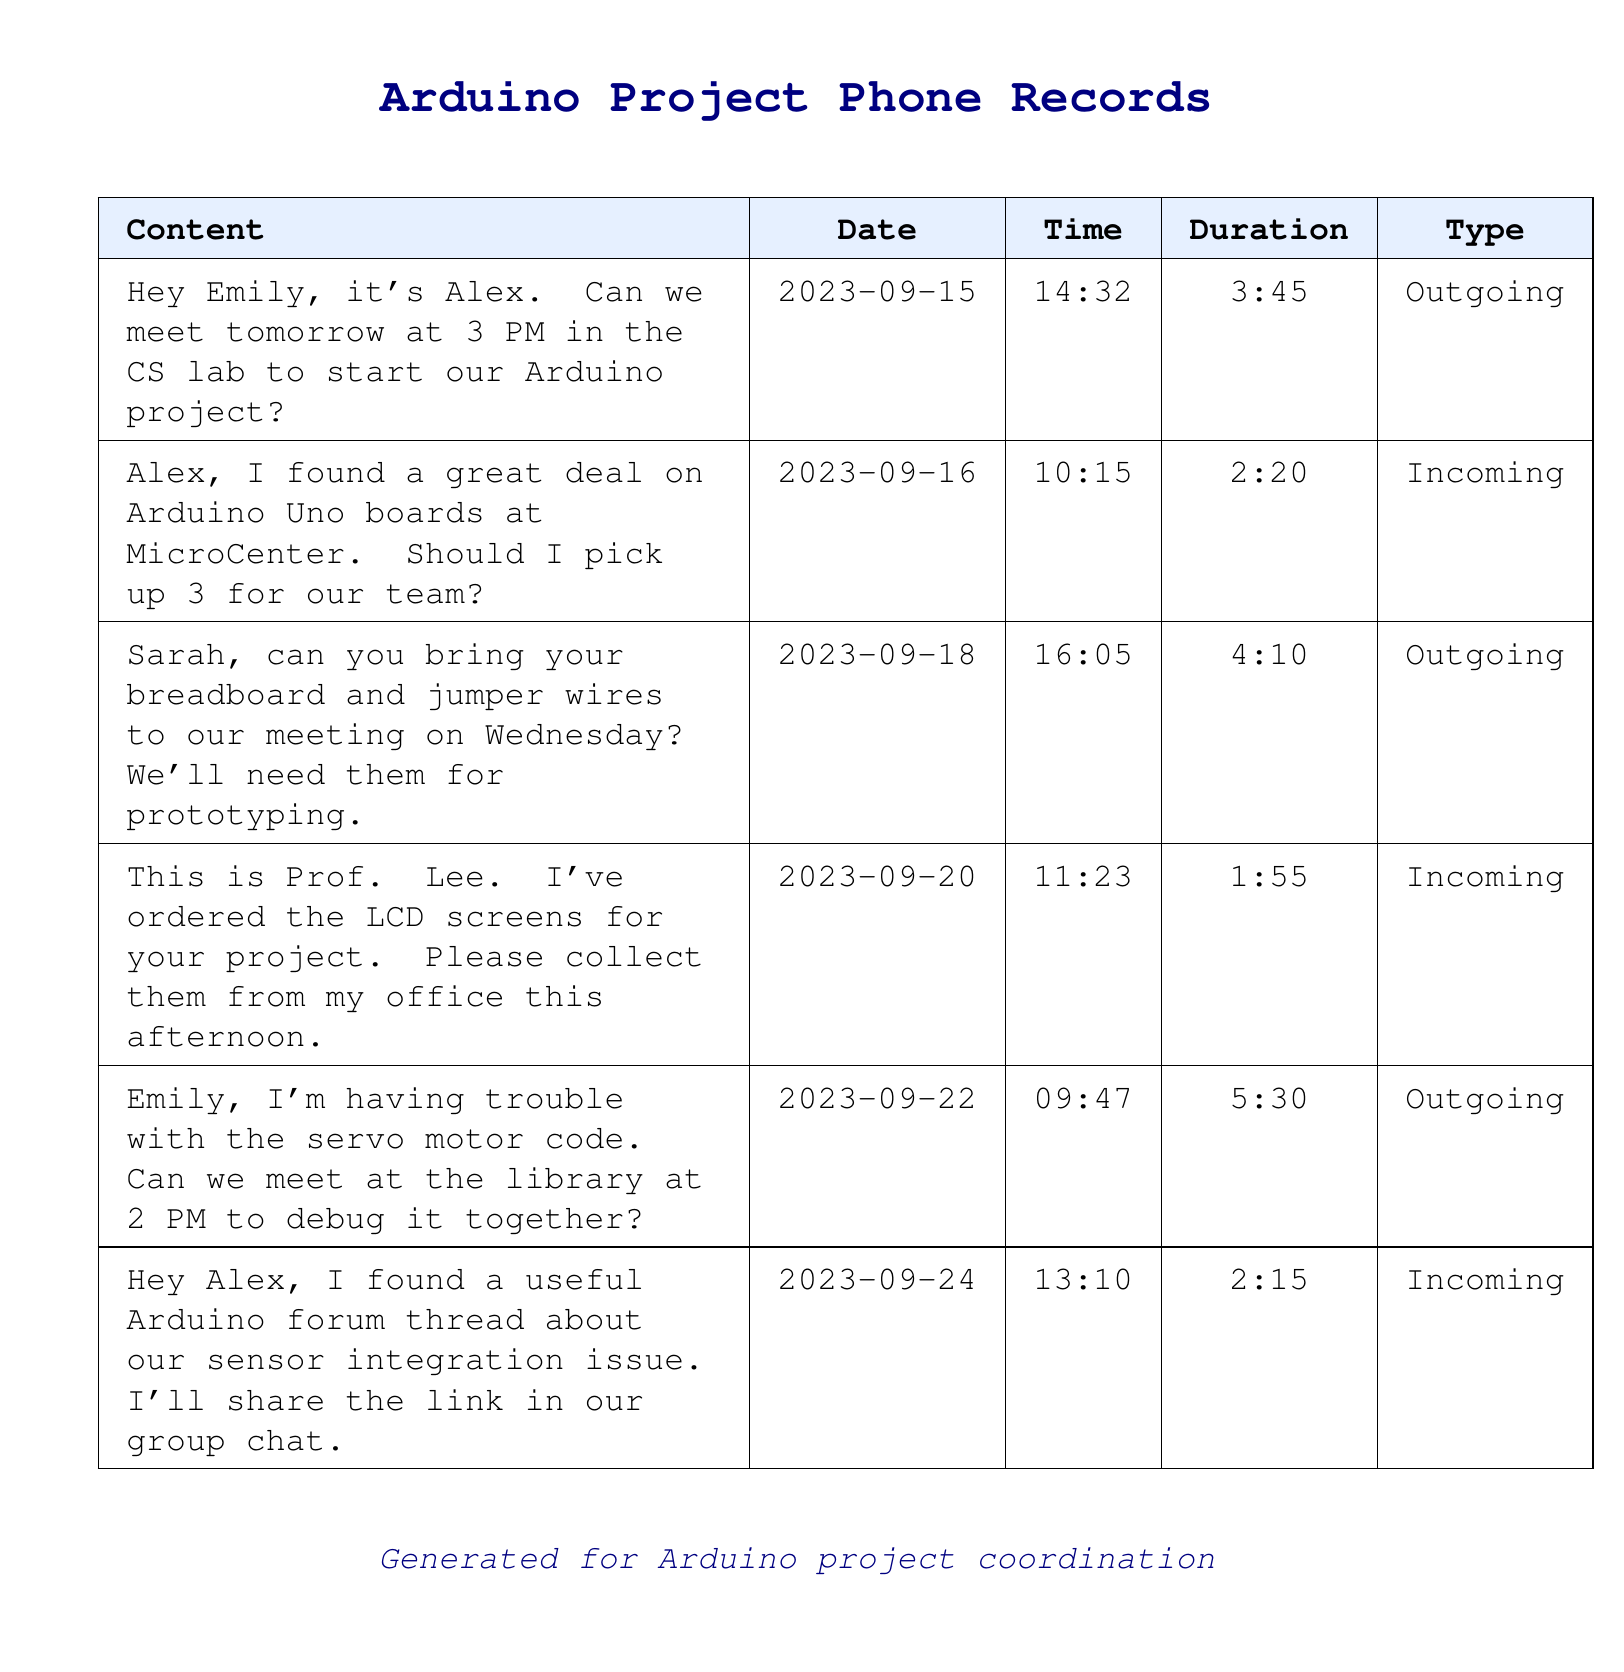What is the date of the message from Alex to Emily? The date of the message from Alex to Emily is captured in the first row of the table, which indicates he sent it on September 15, 2023.
Answer: 2023-09-15 How long was the outgoing message regarding the servo motor code? The duration for the outgoing message about the servo motor code is indicated in the table as 5 minutes and 30 seconds.
Answer: 5:30 Who ordered the LCD screens for the project? The document notes that the LCD screens were ordered by Prof. Lee, according to the incoming message on September 20.
Answer: Prof. Lee What did Sarah need to bring to the meeting? The outgoing message mentions that Sarah is asked to bring her breadboard and jumper wires for the meeting.
Answer: Breadboard and jumper wires How many Arduino Uno boards did Alex suggest should be picked up? The incoming message indicates that Alex found a deal for 3 Arduino Uno boards that could be picked up.
Answer: 3 What was Emily's concern in her message? Emily's message expressed her concern about having trouble with the servo motor code and requested a meeting to debug it together.
Answer: Servo motor code How many messages were sent on a specific day, September 22? The document contains a row indicating a single outgoing message sent on September 22, 2023.
Answer: 1 What time was the meeting scheduled in the CS lab? The first outgoing message specifies a meeting time at 3 PM, coordinated for the next day.
Answer: 3 PM What is the purpose of the document summarized in the footer? The footer clarifies that the document is generated for coordinating the Arduino project among classmates.
Answer: Project coordination 